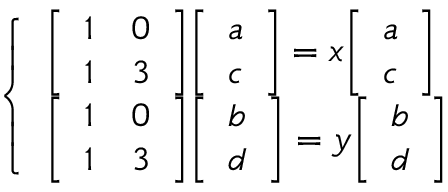Convert formula to latex. <formula><loc_0><loc_0><loc_500><loc_500>{ \left \{ \begin{array} { l l } { { \left [ \begin{array} { l l } { 1 } & { 0 } \\ { 1 } & { 3 } \end{array} \right ] } { \left [ \begin{array} { l } { a } \\ { c } \end{array} \right ] } = x { \left [ \begin{array} { l } { a } \\ { c } \end{array} \right ] } } \\ { { \left [ \begin{array} { l l } { 1 } & { 0 } \\ { 1 } & { 3 } \end{array} \right ] } { \left [ \begin{array} { l } { b } \\ { d } \end{array} \right ] } = y { \left [ \begin{array} { l } { b } \\ { d } \end{array} \right ] } } \end{array} }</formula> 